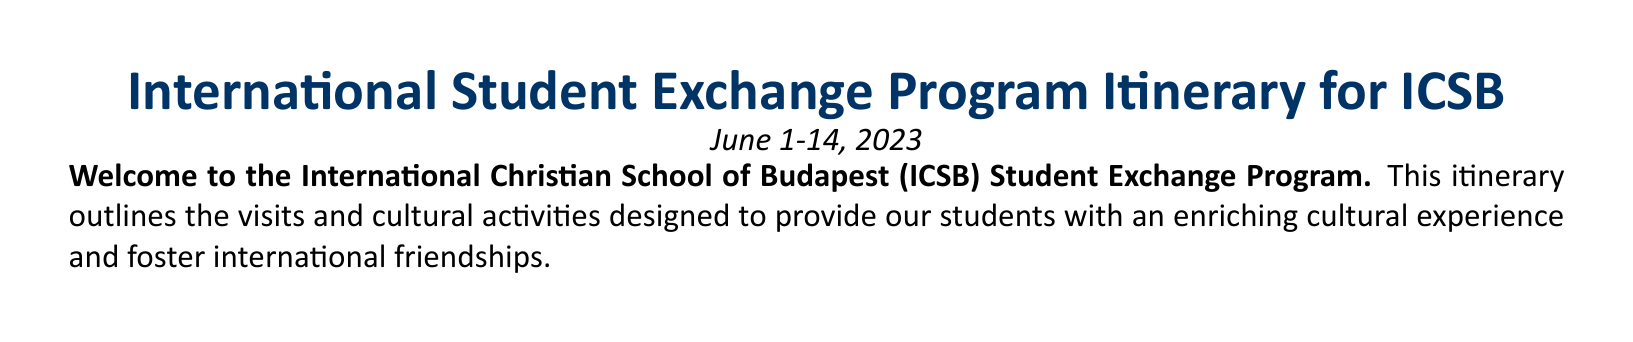What are the dates of the program? The program takes place from June 1 to June 14, 2023.
Answer: June 1-14, 2023 Who is the Program Coordinator? The document specifies the contact information for the Program Coordinator.
Answer: Ms. Jennifer Smith What is scheduled for Day 3? Day 3 has a specific itinerary that includes a day trip to Vienna.
Answer: Day Trip to Vienna, Austria Where will the farewell party be held? The farewell party is mentioned to take place at a specific location in the document.
Answer: ICSB Campus How many days are dedicated to educational workshops? The document outlines activities over a specific period, highlighting educational workshops.
Answer: 2 days What activity takes place on Day 5? Day 5 includes a service project in the afternoon, showcasing a community engagement activity.
Answer: Service Project at a Local Orphanage What type of activity is scheduled for Day 12? The itinerary for Day 12 includes a specific cultural experience that is unique to the region.
Answer: Visit to Etyek Wine Region Which restaurant serves lunch on Day 6? The document lists specific dining locations for each day, including Day 6.
Answer: Márga Bisztró What is included in the Day 4 schedule? Day 4 has a range of planned activities that reflect the cultural experience aimed for the students.
Answer: Hungarian Language Workshop, Lunch at Café Dumaszínház, Visit to the Hungarian Parliament Building, Danube River Cruise 